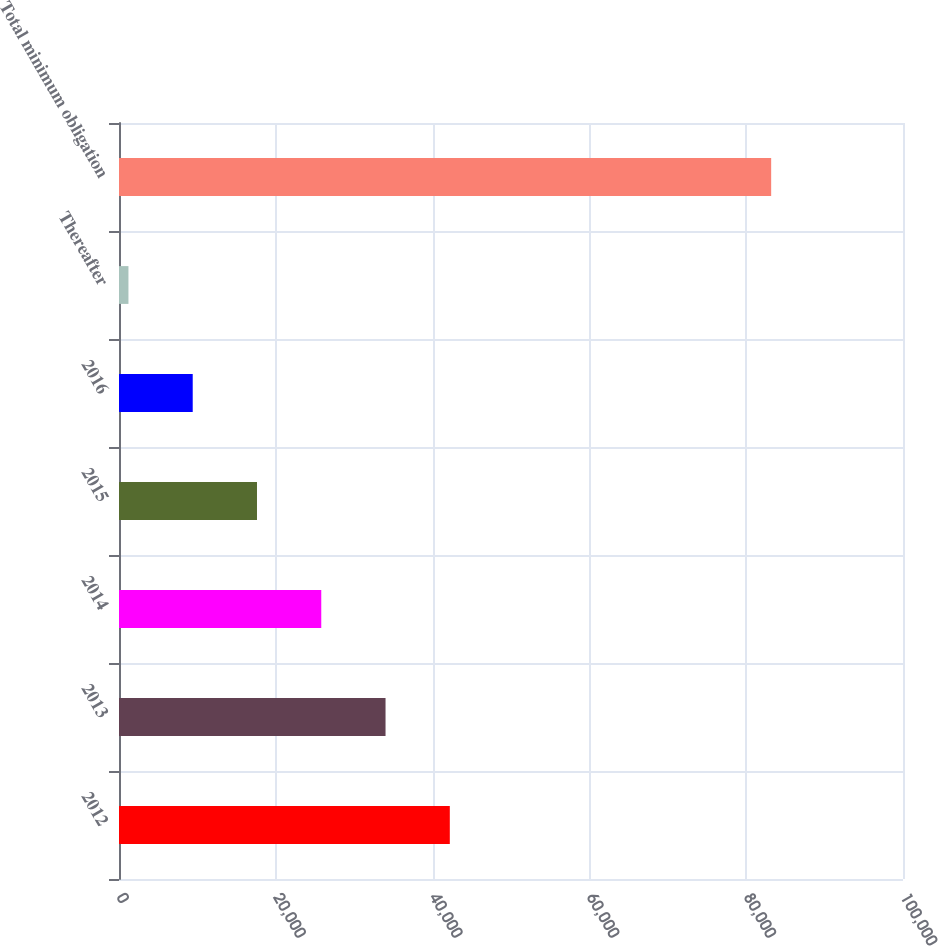<chart> <loc_0><loc_0><loc_500><loc_500><bar_chart><fcel>2012<fcel>2013<fcel>2014<fcel>2015<fcel>2016<fcel>Thereafter<fcel>Total minimum obligation<nl><fcel>42195<fcel>33997<fcel>25799<fcel>17601<fcel>9403<fcel>1205<fcel>83185<nl></chart> 